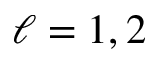<formula> <loc_0><loc_0><loc_500><loc_500>\ell = 1 , 2</formula> 